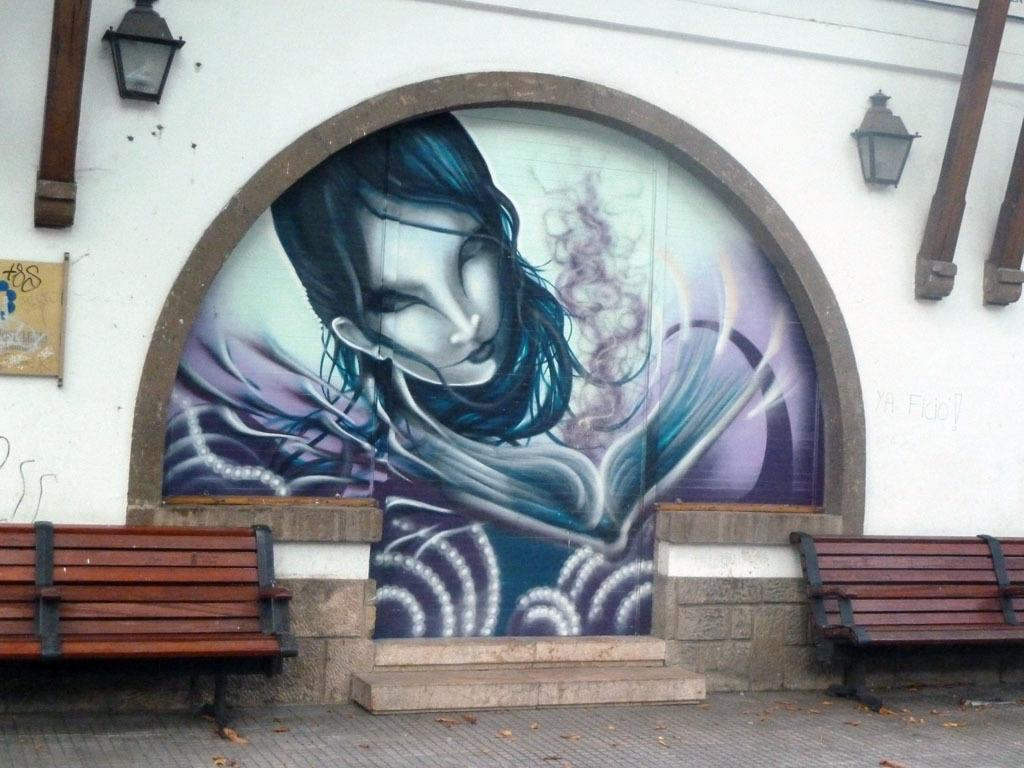How many benches are present in the image? There are 2 benches on either side in the image. What can be found on the wall in the image? There are 2 lamps on the wall in the image. What is the main object in the center of the image? There is a painting in the center of the image. What type of lawyer is depicted in the painting in the image? There is no lawyer depicted in the painting in the image; it is not mentioned in the provided facts. 